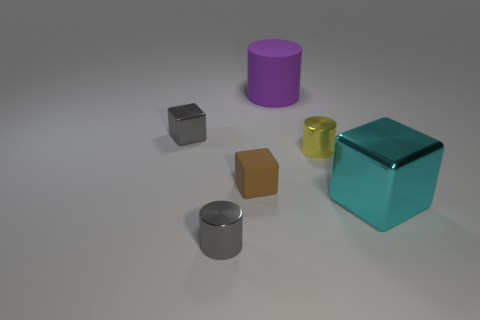Add 3 big metallic objects. How many objects exist? 9 Add 1 cylinders. How many cylinders exist? 4 Subtract 1 cyan cubes. How many objects are left? 5 Subtract all small blocks. Subtract all yellow metallic objects. How many objects are left? 3 Add 1 cylinders. How many cylinders are left? 4 